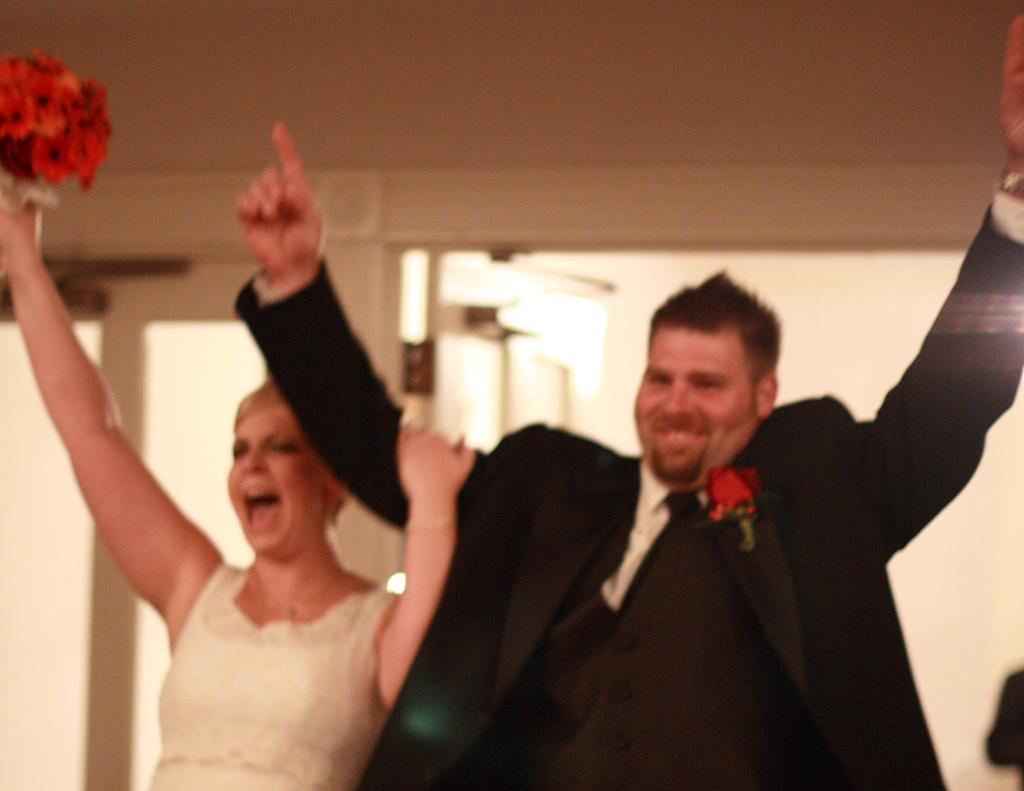What is happening in the image? There are people standing in the image. Can you describe what the woman is holding? The woman is holding a bouquet in her hand. What is the man wearing? The man is wearing a suit. What type of board is the man using to surf in the image? There is no board or surfing activity present in the image. 